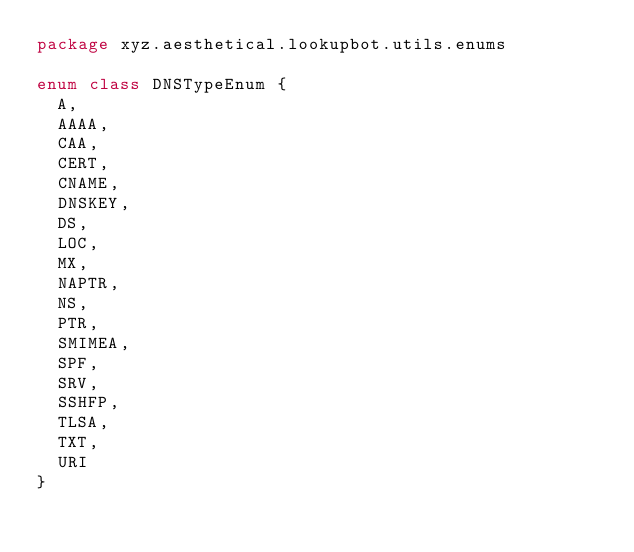<code> <loc_0><loc_0><loc_500><loc_500><_Kotlin_>package xyz.aesthetical.lookupbot.utils.enums

enum class DNSTypeEnum {
  A,
  AAAA,
  CAA,
  CERT,
  CNAME,
  DNSKEY,
  DS,
  LOC,
  MX,
  NAPTR,
  NS,
  PTR,
  SMIMEA,
  SPF,
  SRV,
  SSHFP,
  TLSA,
  TXT,
  URI
}</code> 